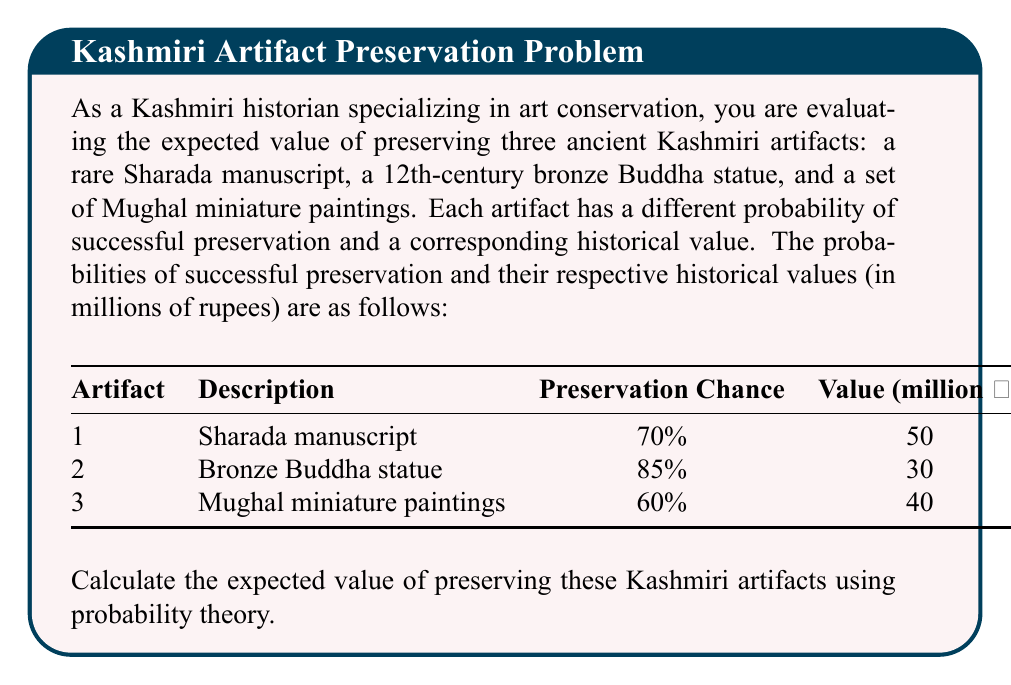Solve this math problem. To calculate the expected value of preserving the Kashmiri artifacts, we need to use the concept of expected value from probability theory. The expected value is calculated by multiplying the probability of each outcome by its corresponding value and then summing these products.

Let's calculate the expected value for each artifact:

1. Sharada manuscript:
   Probability of preservation = 0.70
   Value = 50 million rupees
   Expected value = $0.70 \times 50 = 35$ million rupees

2. Bronze Buddha statue:
   Probability of preservation = 0.85
   Value = 30 million rupees
   Expected value = $0.85 \times 30 = 25.5$ million rupees

3. Mughal miniature paintings:
   Probability of preservation = 0.60
   Value = 40 million rupees
   Expected value = $0.60 \times 40 = 24$ million rupees

Now, to find the total expected value of preserving all three artifacts, we sum the individual expected values:

Total Expected Value = $35 + 25.5 + 24 = 84.5$ million rupees

Therefore, the expected value of preserving these Kashmiri artifacts is 84.5 million rupees.
Answer: $$84.5 \text{ million rupees}$$ 